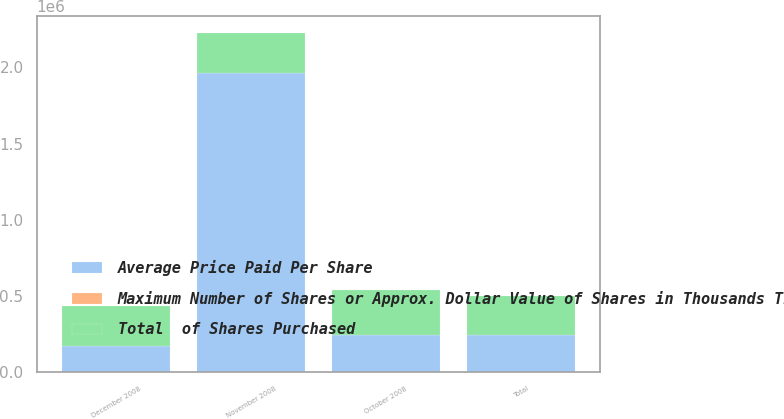Convert chart. <chart><loc_0><loc_0><loc_500><loc_500><stacked_bar_chart><ecel><fcel>October 2008<fcel>November 2008<fcel>December 2008<fcel>Total<nl><fcel>Average Price Paid Per Share<fcel>242445<fcel>1.96208e+06<fcel>175258<fcel>242445<nl><fcel>Maximum Number of Shares or Approx. Dollar Value of Shares in Thousands That May Yet Be Purchased Under the Plans or Programs<fcel>22.58<fcel>19.83<fcel>15.86<fcel>19.82<nl><fcel>Total  of Shares Purchased<fcel>300000<fcel>261096<fcel>258317<fcel>258317<nl></chart> 